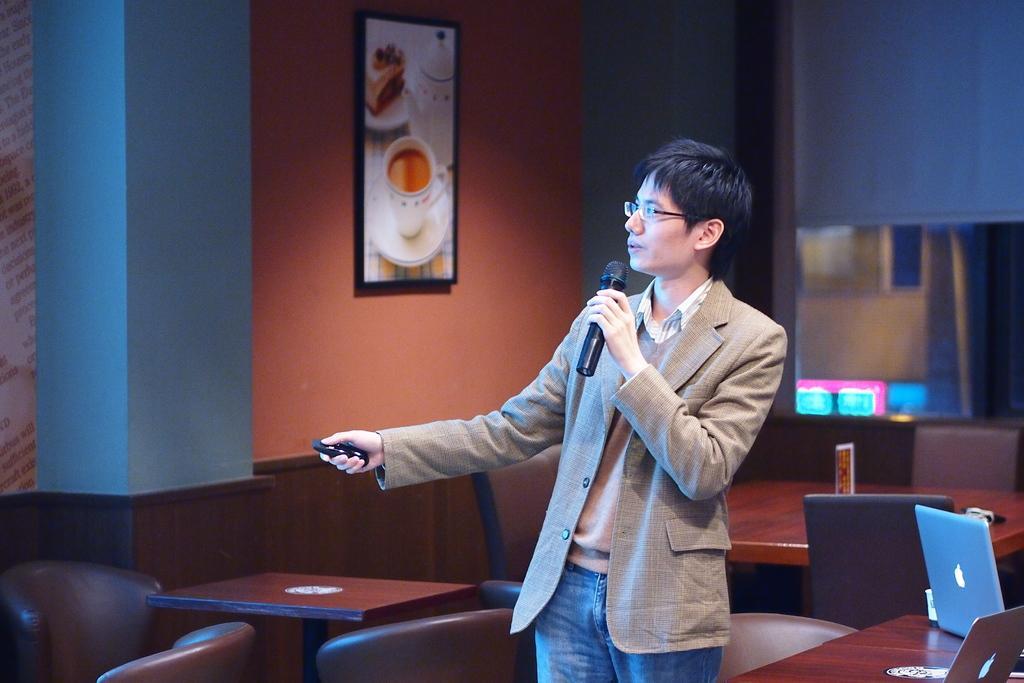Please provide a concise description of this image. In this image there is a man wearing blazer, is holding a mic in his hands and speaking. On the right side of the image there is a blue color laptop placed on the table. In the background there is a photo frame attached to the wall. 